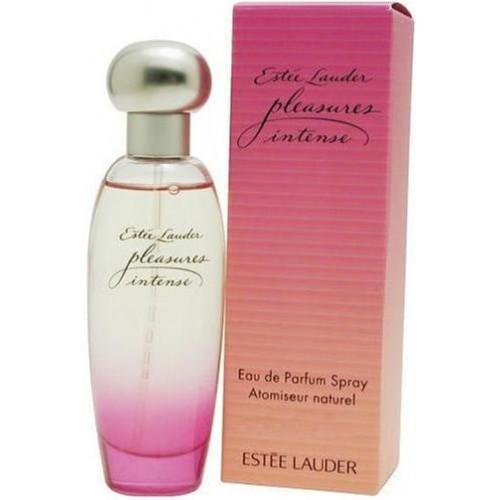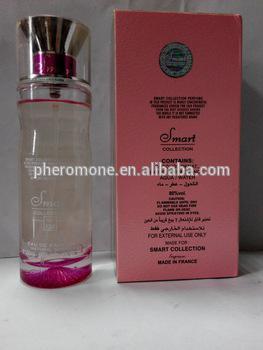The first image is the image on the left, the second image is the image on the right. For the images displayed, is the sentence "The  glass perfume bottle furthest to the right in the right image is purple." factually correct? Answer yes or no. No. 